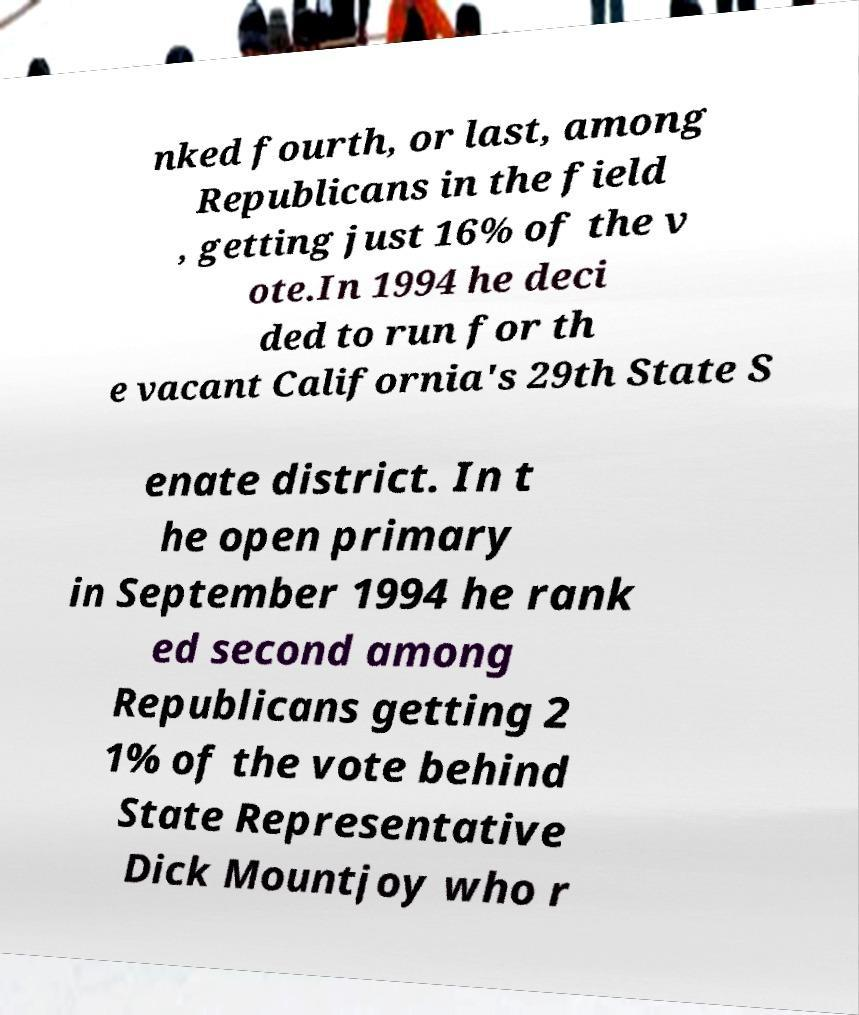Could you extract and type out the text from this image? nked fourth, or last, among Republicans in the field , getting just 16% of the v ote.In 1994 he deci ded to run for th e vacant California's 29th State S enate district. In t he open primary in September 1994 he rank ed second among Republicans getting 2 1% of the vote behind State Representative Dick Mountjoy who r 